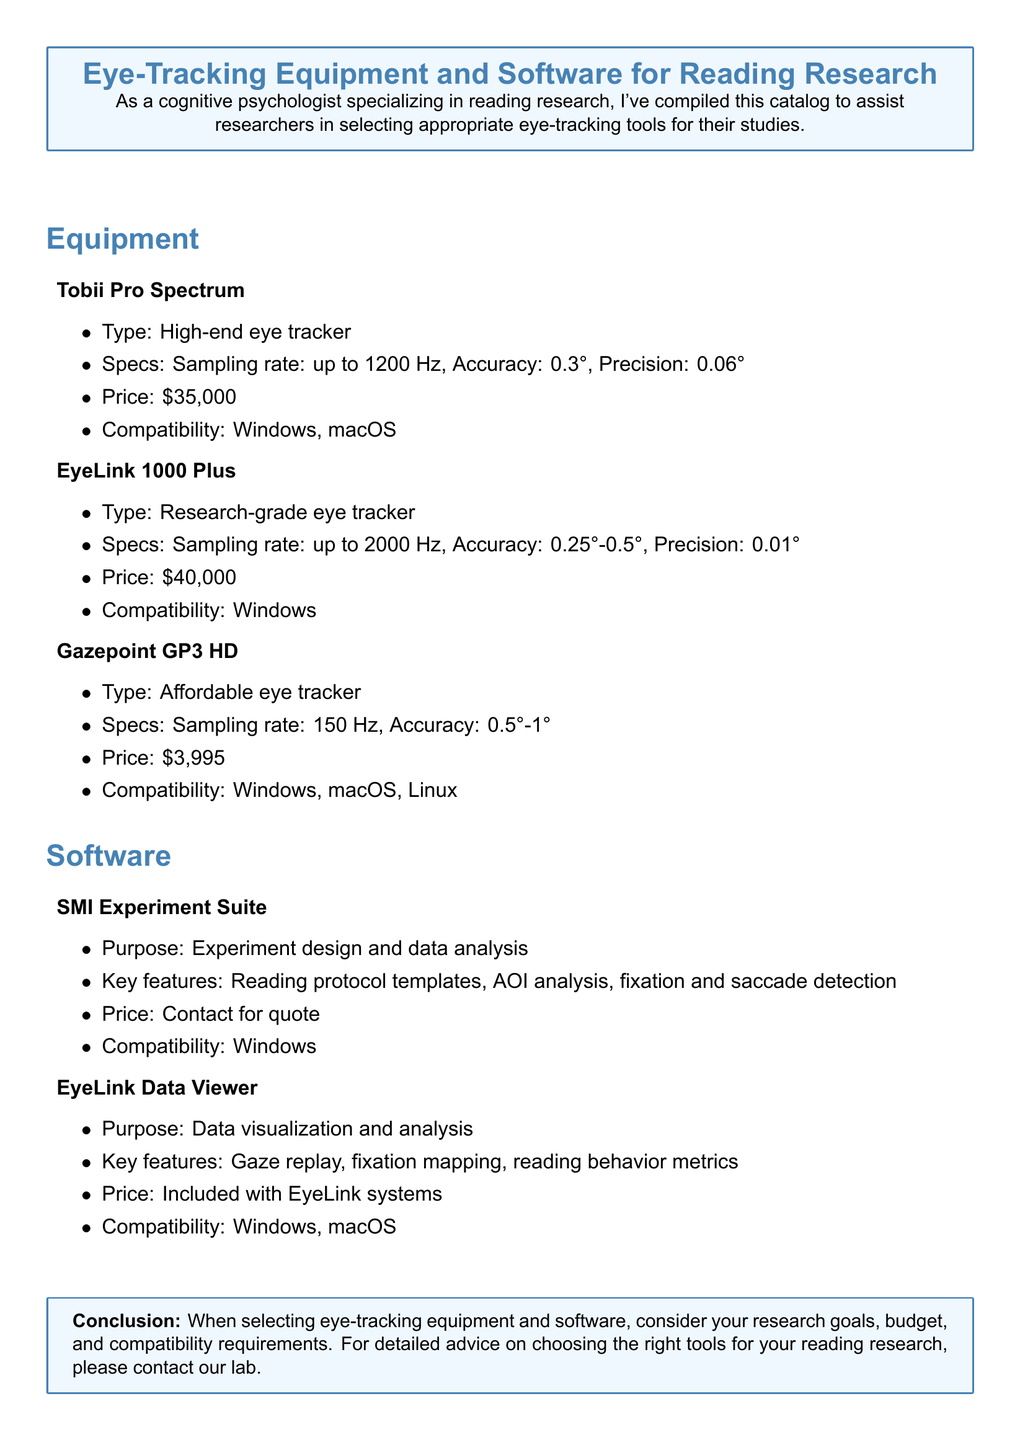What is the price of the Tobii Pro Spectrum? The price of the Tobii Pro Spectrum is listed in the document, which is $35,000.
Answer: $35,000 What is the sampling rate of the EyeLink 1000 Plus? The document specifies that the sampling rate of the EyeLink 1000 Plus is up to 2000 Hz.
Answer: up to 2000 Hz Which operating systems are compatible with Gazepoint GP3 HD? The document lists the compatibility for Gazepoint GP3 HD, which includes Windows, macOS, and Linux.
Answer: Windows, macOS, Linux What is the purpose of the SMI Experiment Suite? The primary purpose of the SMI Experiment Suite, according to the document, is for experiment design and data analysis.
Answer: Experiment design and data analysis What is the accuracy range for the EyeLink 1000 Plus? The document indicates the accuracy range for the EyeLink 1000 Plus is between 0.25° and 0.5°.
Answer: 0.25°-0.5° Which eye tracker has the highest price? By evaluating the prices listed in the document, the EyeLink 1000 Plus is identified as having the highest price.
Answer: EyeLink 1000 Plus What key feature is offered by EyeLink Data Viewer? According to the document, one of the key features of EyeLink Data Viewer is gaze replay.
Answer: Gaze replay What factors should be considered when selecting eye-tracking equipment? The document advises on considering research goals, budget, and compatibility requirements when selecting tools.
Answer: Research goals, budget, compatibility requirements 